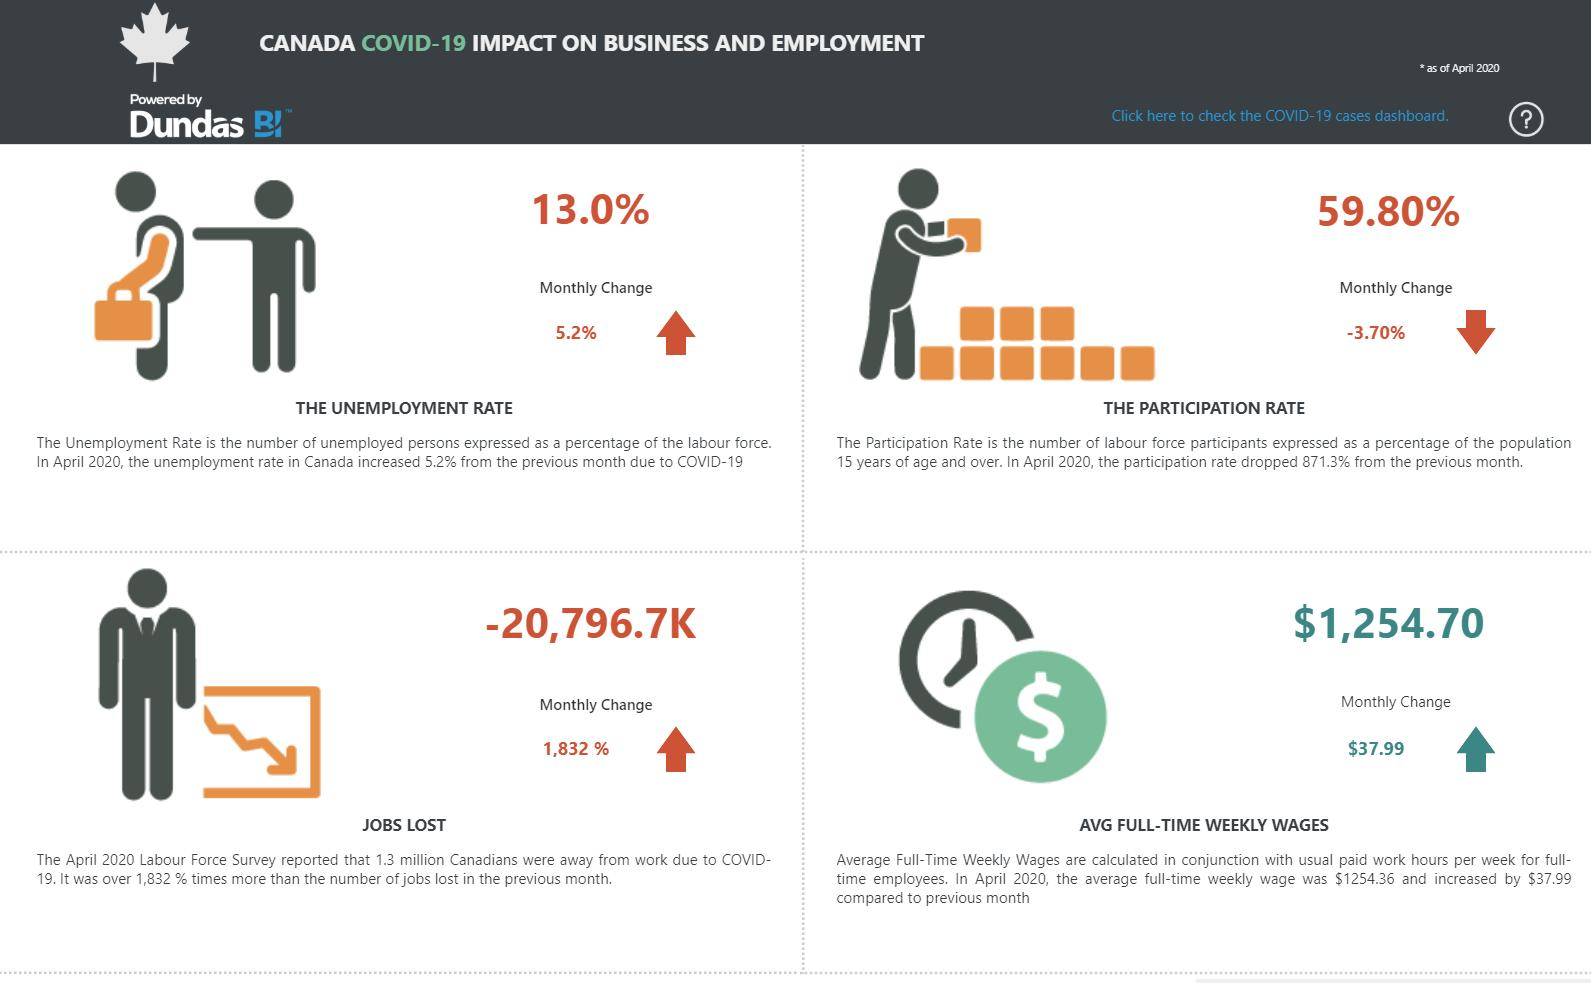Outline some significant characteristics in this image. The combination of the total unemployment rate and the participation rate is 72.8%. 